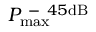Convert formula to latex. <formula><loc_0><loc_0><loc_500><loc_500>P _ { \max } ^ { - 4 5 d B }</formula> 